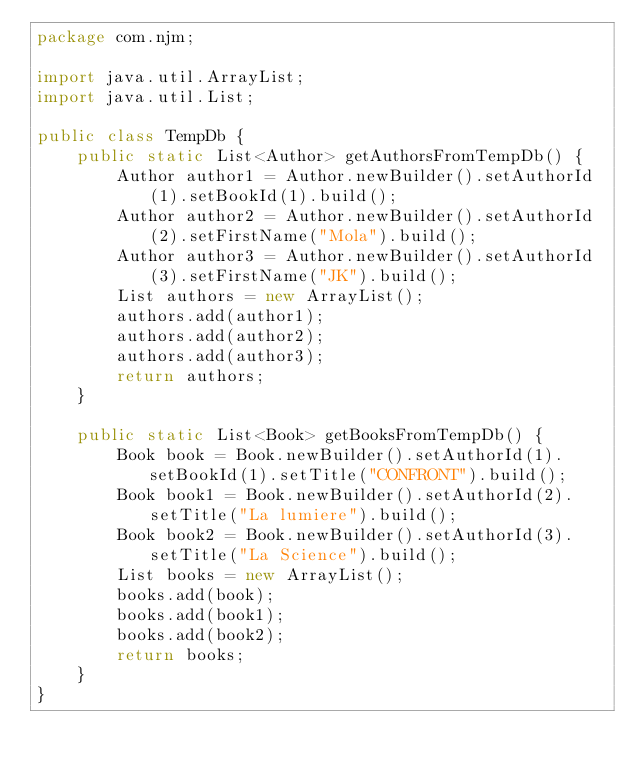Convert code to text. <code><loc_0><loc_0><loc_500><loc_500><_Java_>package com.njm;

import java.util.ArrayList;
import java.util.List;

public class TempDb {
    public static List<Author> getAuthorsFromTempDb() {
        Author author1 = Author.newBuilder().setAuthorId(1).setBookId(1).build();
        Author author2 = Author.newBuilder().setAuthorId(2).setFirstName("Mola").build();
        Author author3 = Author.newBuilder().setAuthorId(3).setFirstName("JK").build();
        List authors = new ArrayList();
        authors.add(author1);
        authors.add(author2);
        authors.add(author3);
        return authors;
    }

    public static List<Book> getBooksFromTempDb() {
        Book book = Book.newBuilder().setAuthorId(1).setBookId(1).setTitle("CONFRONT").build();
        Book book1 = Book.newBuilder().setAuthorId(2).setTitle("La lumiere").build();
        Book book2 = Book.newBuilder().setAuthorId(3).setTitle("La Science").build();
        List books = new ArrayList();
        books.add(book);
        books.add(book1);
        books.add(book2);
        return books;
    }
}
</code> 